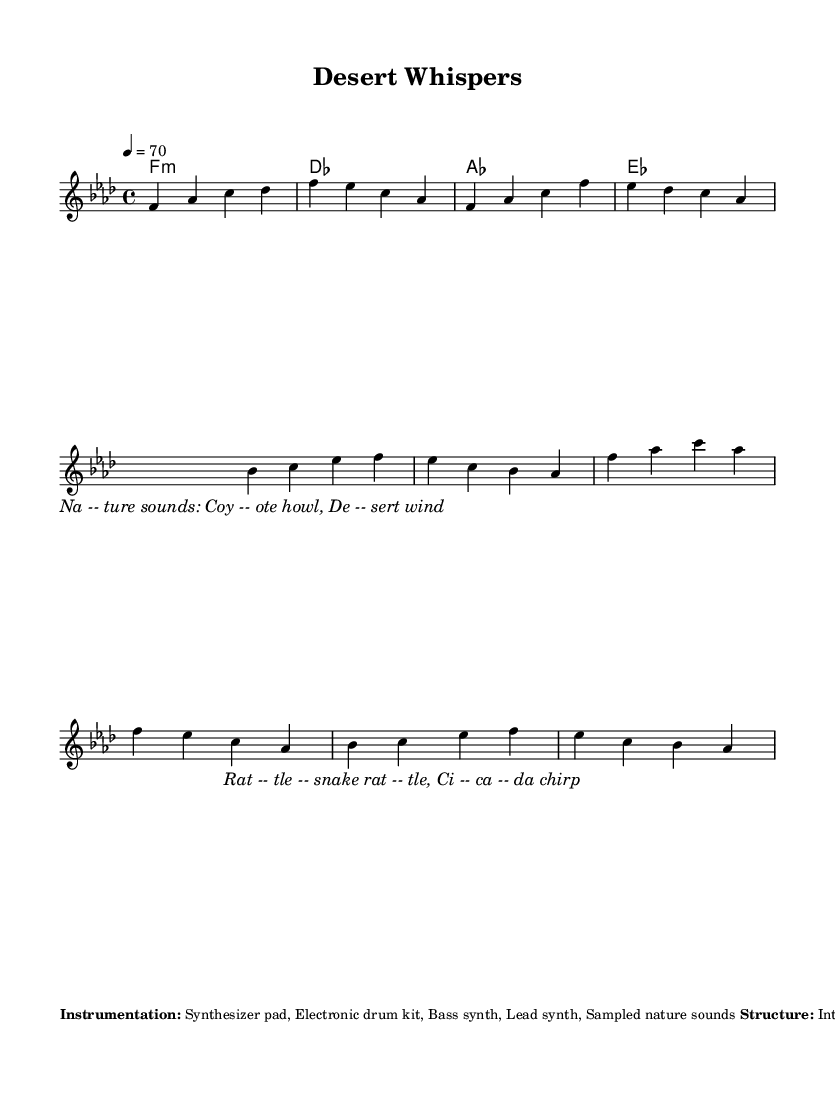What is the key signature of this music? The key signature is F minor, indicated at the beginning of the score. It is recognized by the presence of four flats: B-flat, E-flat, A-flat, and D-flat.
Answer: F minor What is the time signature of this music? The time signature is 4/4, which means there are four beats in each measure and a quarter note receives one beat. This is indicated at the start of the score.
Answer: 4/4 What is the tempo marking for this piece? The tempo marking is indicated as 4 = 70, which means the quarter note should be played at a speed of 70 beats per minute.
Answer: 70 How many measures are in the structure of the piece? The structure consists of several sections: Intro, Verse, Chorus, Break, Verse, Chorus, and Outro, totaling seven parts. Analyzing the written music, we note the measures correspond to these sections.
Answer: 7 What instruments are used in this composition? The composition includes a synthesizer pad, electronic drum kit, bass synth, lead synth, and sampled nature sounds. This information is outlined in the instrumentation section of the score.
Answer: Synthesizer pad, Electronic drum kit, Bass synth, Lead synth, Sampled nature sounds What nature samples are featured in this piece? The piece features nature sounds such as a coyote howl, desert wind, rattlesnake rattle, and cicada chirp. These samples are highlighted as part of the lyrics and notes within the score.
Answer: Coyote howl, desert wind, rattlesnake rattle, cicada chirp 